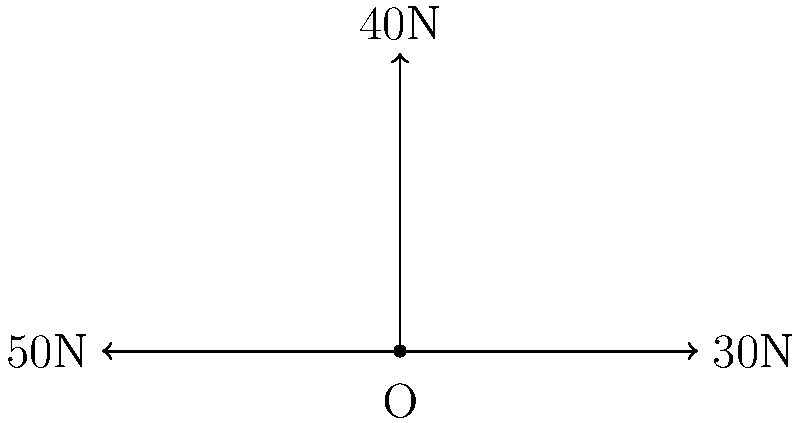In a political tug-of-war scenario, three factions are pulling on a central policy point (O) with different force vectors. The conservative faction pulls east with 30N, the progressive faction pulls north with 40N, and Mr. Kirksey's moderate faction pulls west with 50N. What is the magnitude of the resultant force vector acting on the policy point? To solve this problem, we'll use vector addition and the Pythagorean theorem:

1) First, let's break down the forces into their x and y components:
   Conservative (east): $F_x = 30N$, $F_y = 0N$
   Progressive (north): $F_x = 0N$, $F_y = 40N$
   Moderate (west): $F_x = -50N$, $F_y = 0N$

2) Now, we sum the forces in each direction:
   $F_x(\text{total}) = 30N + 0N + (-50N) = -20N$
   $F_y(\text{total}) = 0N + 40N + 0N = 40N$

3) The resultant force vector has components $(-20N, 40N)$

4) To find the magnitude of this vector, we use the Pythagorean theorem:
   $F_{\text{resultant}} = \sqrt{(-20N)^2 + (40N)^2}$

5) Simplify:
   $F_{\text{resultant}} = \sqrt{400N^2 + 1600N^2} = \sqrt{2000N^2} = 20\sqrt{5}N$

Therefore, the magnitude of the resultant force vector is $20\sqrt{5}N$ or approximately 44.72N.
Answer: $20\sqrt{5}N$ 